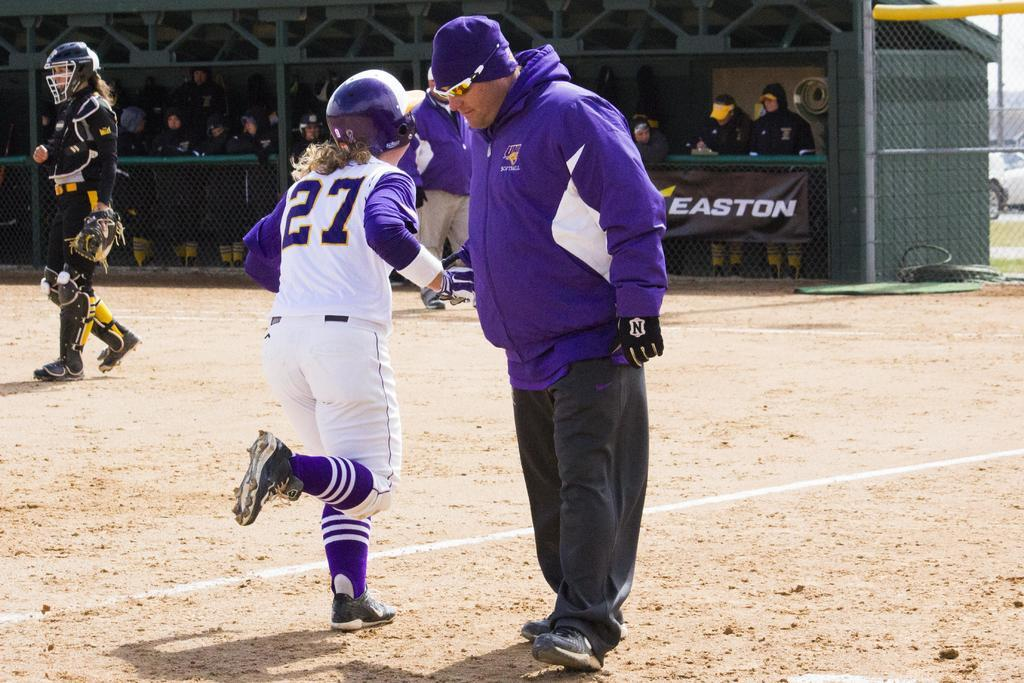<image>
Write a terse but informative summary of the picture. Softball players on a field sponsored by Easton 